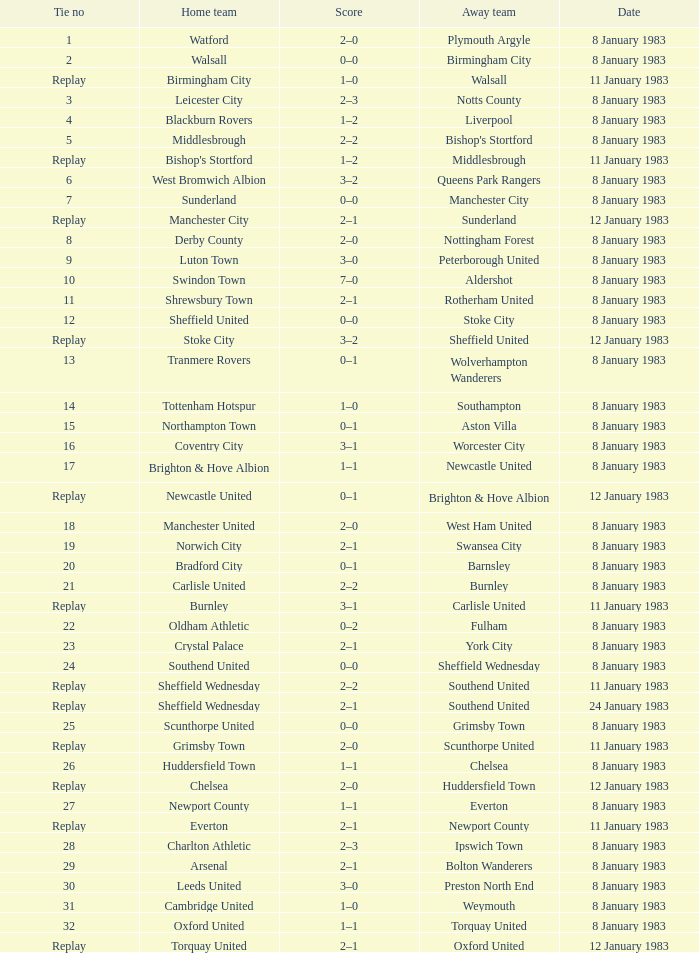During the match where southampton played as the away team, which team was hosting? Tottenham Hotspur. 